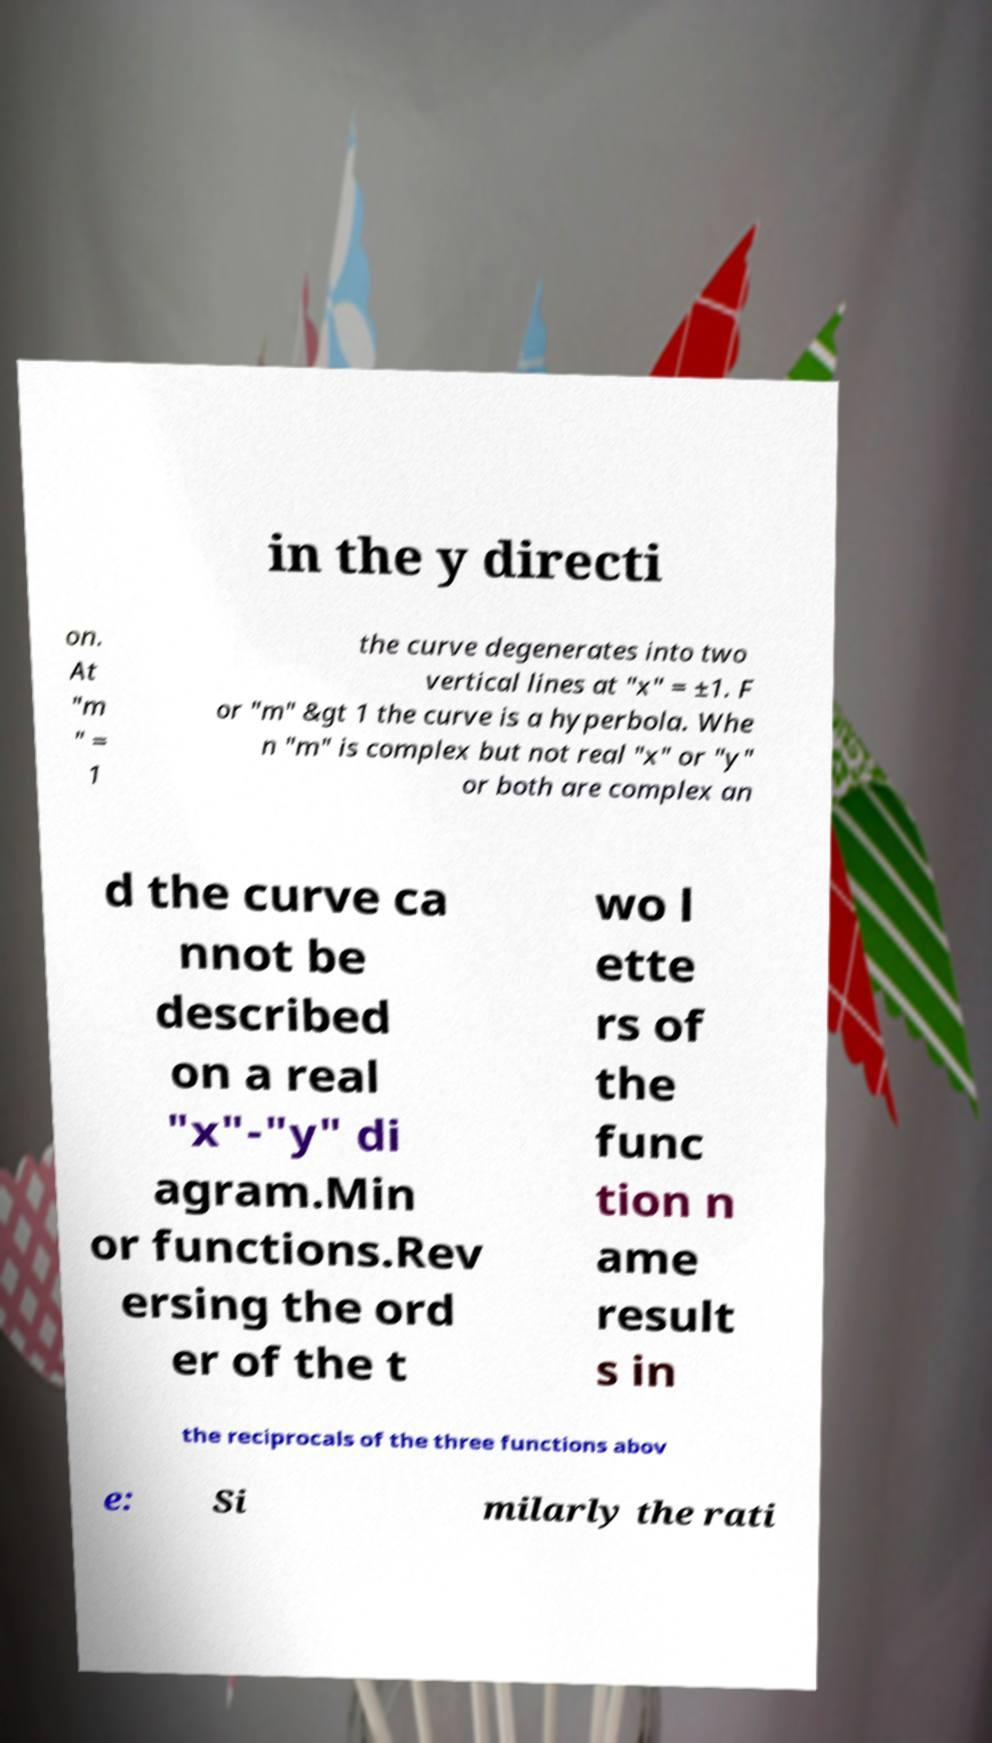Could you assist in decoding the text presented in this image and type it out clearly? in the y directi on. At "m " = 1 the curve degenerates into two vertical lines at "x" = ±1. F or "m" &gt 1 the curve is a hyperbola. Whe n "m" is complex but not real "x" or "y" or both are complex an d the curve ca nnot be described on a real "x"-"y" di agram.Min or functions.Rev ersing the ord er of the t wo l ette rs of the func tion n ame result s in the reciprocals of the three functions abov e: Si milarly the rati 